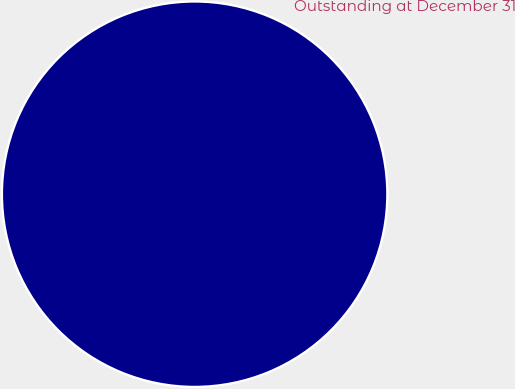Convert chart to OTSL. <chart><loc_0><loc_0><loc_500><loc_500><pie_chart><fcel>Outstanding at December 31<nl><fcel>100.0%<nl></chart> 